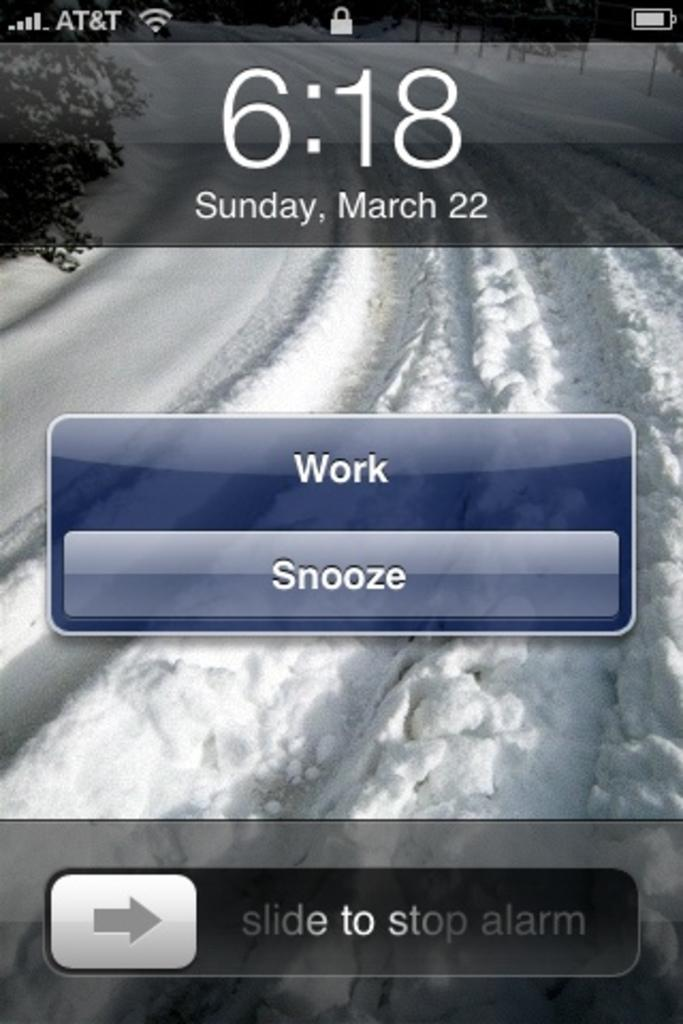<image>
Relay a brief, clear account of the picture shown. a cell phone screen showing the time as 6:18 